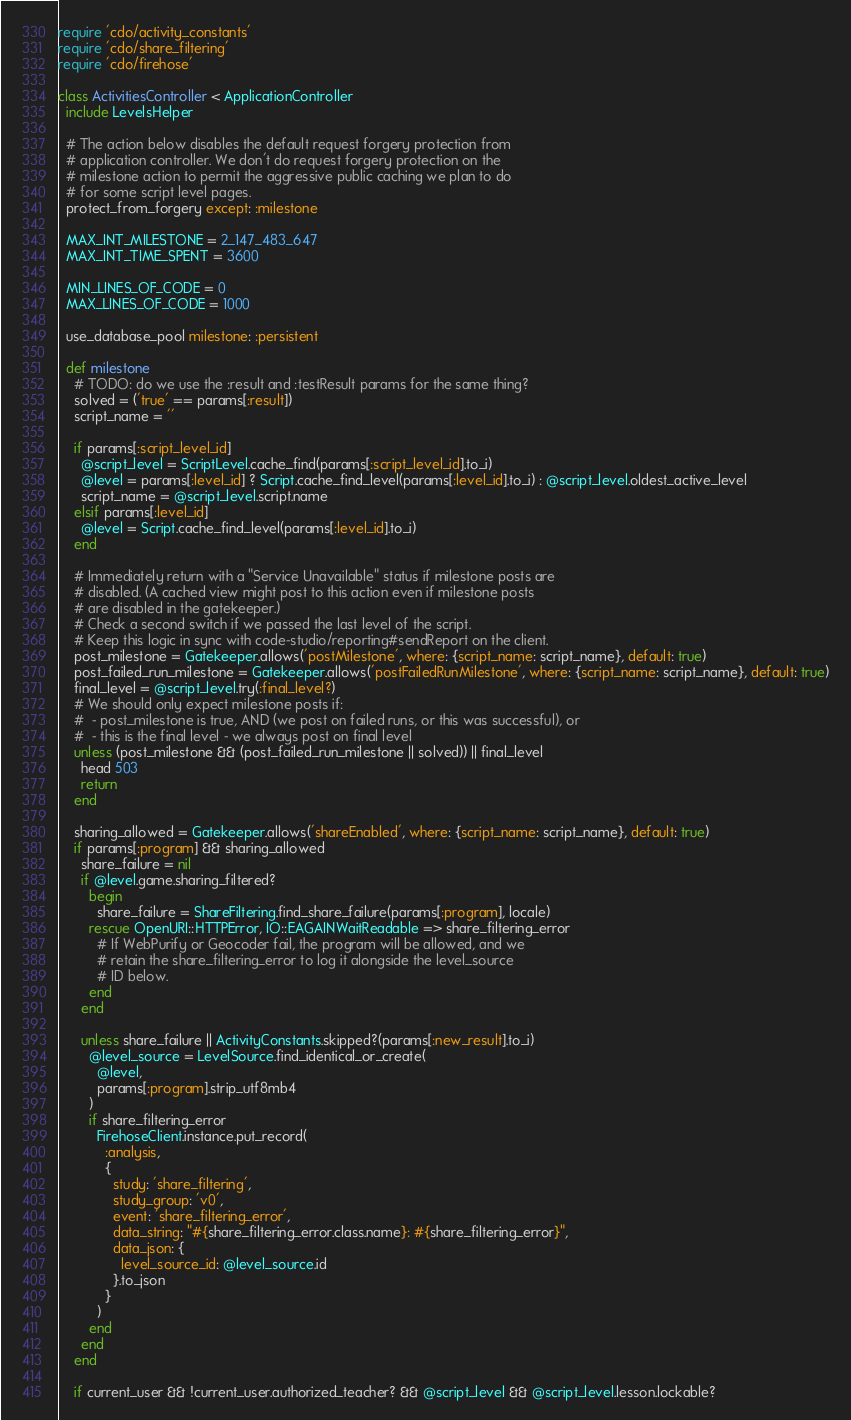<code> <loc_0><loc_0><loc_500><loc_500><_Ruby_>require 'cdo/activity_constants'
require 'cdo/share_filtering'
require 'cdo/firehose'

class ActivitiesController < ApplicationController
  include LevelsHelper

  # The action below disables the default request forgery protection from
  # application controller. We don't do request forgery protection on the
  # milestone action to permit the aggressive public caching we plan to do
  # for some script level pages.
  protect_from_forgery except: :milestone

  MAX_INT_MILESTONE = 2_147_483_647
  MAX_INT_TIME_SPENT = 3600

  MIN_LINES_OF_CODE = 0
  MAX_LINES_OF_CODE = 1000

  use_database_pool milestone: :persistent

  def milestone
    # TODO: do we use the :result and :testResult params for the same thing?
    solved = ('true' == params[:result])
    script_name = ''

    if params[:script_level_id]
      @script_level = ScriptLevel.cache_find(params[:script_level_id].to_i)
      @level = params[:level_id] ? Script.cache_find_level(params[:level_id].to_i) : @script_level.oldest_active_level
      script_name = @script_level.script.name
    elsif params[:level_id]
      @level = Script.cache_find_level(params[:level_id].to_i)
    end

    # Immediately return with a "Service Unavailable" status if milestone posts are
    # disabled. (A cached view might post to this action even if milestone posts
    # are disabled in the gatekeeper.)
    # Check a second switch if we passed the last level of the script.
    # Keep this logic in sync with code-studio/reporting#sendReport on the client.
    post_milestone = Gatekeeper.allows('postMilestone', where: {script_name: script_name}, default: true)
    post_failed_run_milestone = Gatekeeper.allows('postFailedRunMilestone', where: {script_name: script_name}, default: true)
    final_level = @script_level.try(:final_level?)
    # We should only expect milestone posts if:
    #  - post_milestone is true, AND (we post on failed runs, or this was successful), or
    #  - this is the final level - we always post on final level
    unless (post_milestone && (post_failed_run_milestone || solved)) || final_level
      head 503
      return
    end

    sharing_allowed = Gatekeeper.allows('shareEnabled', where: {script_name: script_name}, default: true)
    if params[:program] && sharing_allowed
      share_failure = nil
      if @level.game.sharing_filtered?
        begin
          share_failure = ShareFiltering.find_share_failure(params[:program], locale)
        rescue OpenURI::HTTPError, IO::EAGAINWaitReadable => share_filtering_error
          # If WebPurify or Geocoder fail, the program will be allowed, and we
          # retain the share_filtering_error to log it alongside the level_source
          # ID below.
        end
      end

      unless share_failure || ActivityConstants.skipped?(params[:new_result].to_i)
        @level_source = LevelSource.find_identical_or_create(
          @level,
          params[:program].strip_utf8mb4
        )
        if share_filtering_error
          FirehoseClient.instance.put_record(
            :analysis,
            {
              study: 'share_filtering',
              study_group: 'v0',
              event: 'share_filtering_error',
              data_string: "#{share_filtering_error.class.name}: #{share_filtering_error}",
              data_json: {
                level_source_id: @level_source.id
              }.to_json
            }
          )
        end
      end
    end

    if current_user && !current_user.authorized_teacher? && @script_level && @script_level.lesson.lockable?</code> 